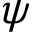<formula> <loc_0><loc_0><loc_500><loc_500>\psi</formula> 